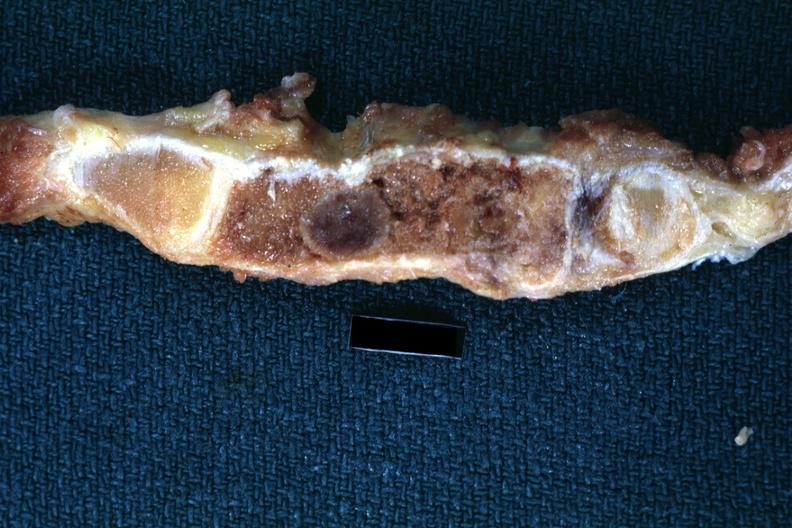what is present?
Answer the question using a single word or phrase. Joints 